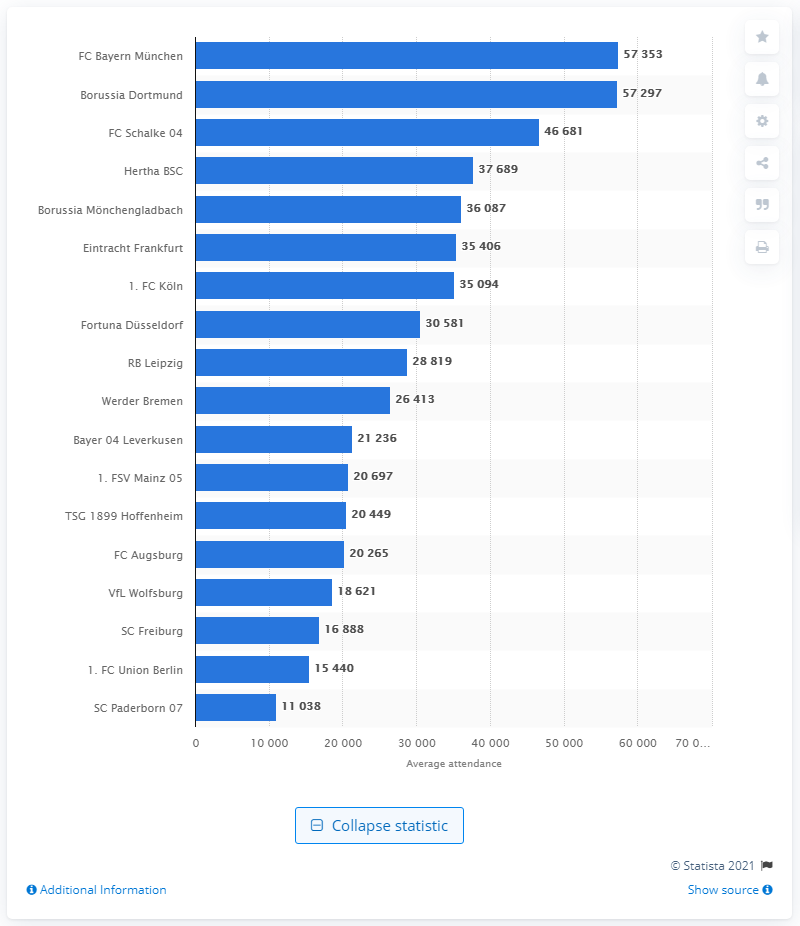Specify some key components in this picture. During the 2019/20 season, SC Paderborn 07 had the lowest attendance among all teams. 